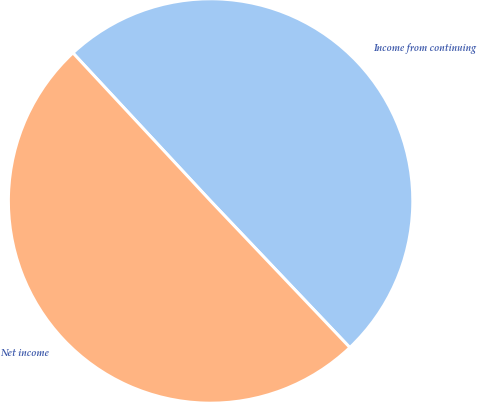Convert chart. <chart><loc_0><loc_0><loc_500><loc_500><pie_chart><fcel>Income from continuing<fcel>Net income<nl><fcel>49.83%<fcel>50.17%<nl></chart> 